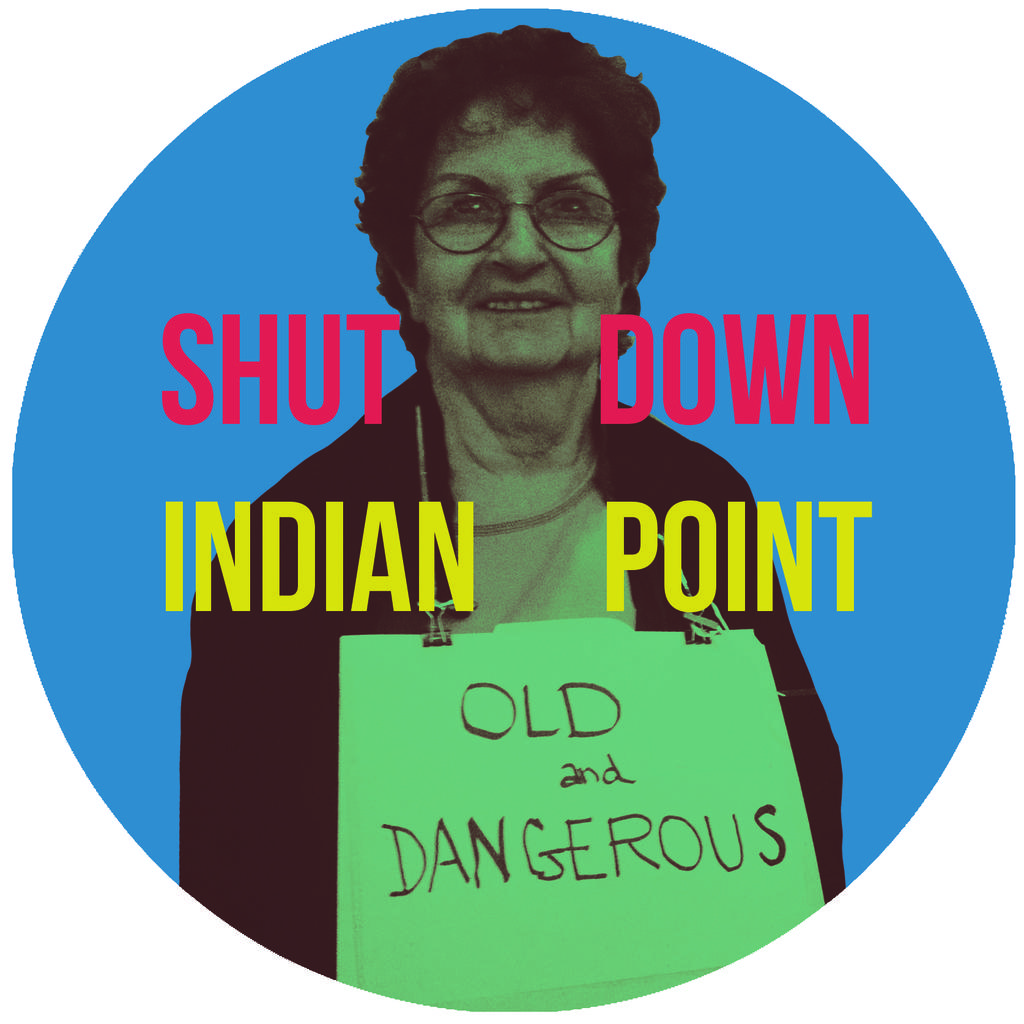What is the main subject in the center of the image? There is a woman wearing a placard in the center of the image. What else can be seen in the center of the image? There is text in the center of the image. What is the color of the background in the image? The background of the image is blue. What is the purpose of the poster in the image? The poster in the image is likely used for conveying a message or promoting an event, given the presence of the woman wearing a placard and the text. Can you tell me how many sponges are depicted on the poster? There are no sponges depicted on the poster; it features a woman wearing a placard and text. What type of popcorn is being served in the image? There is no popcorn present in the image. 